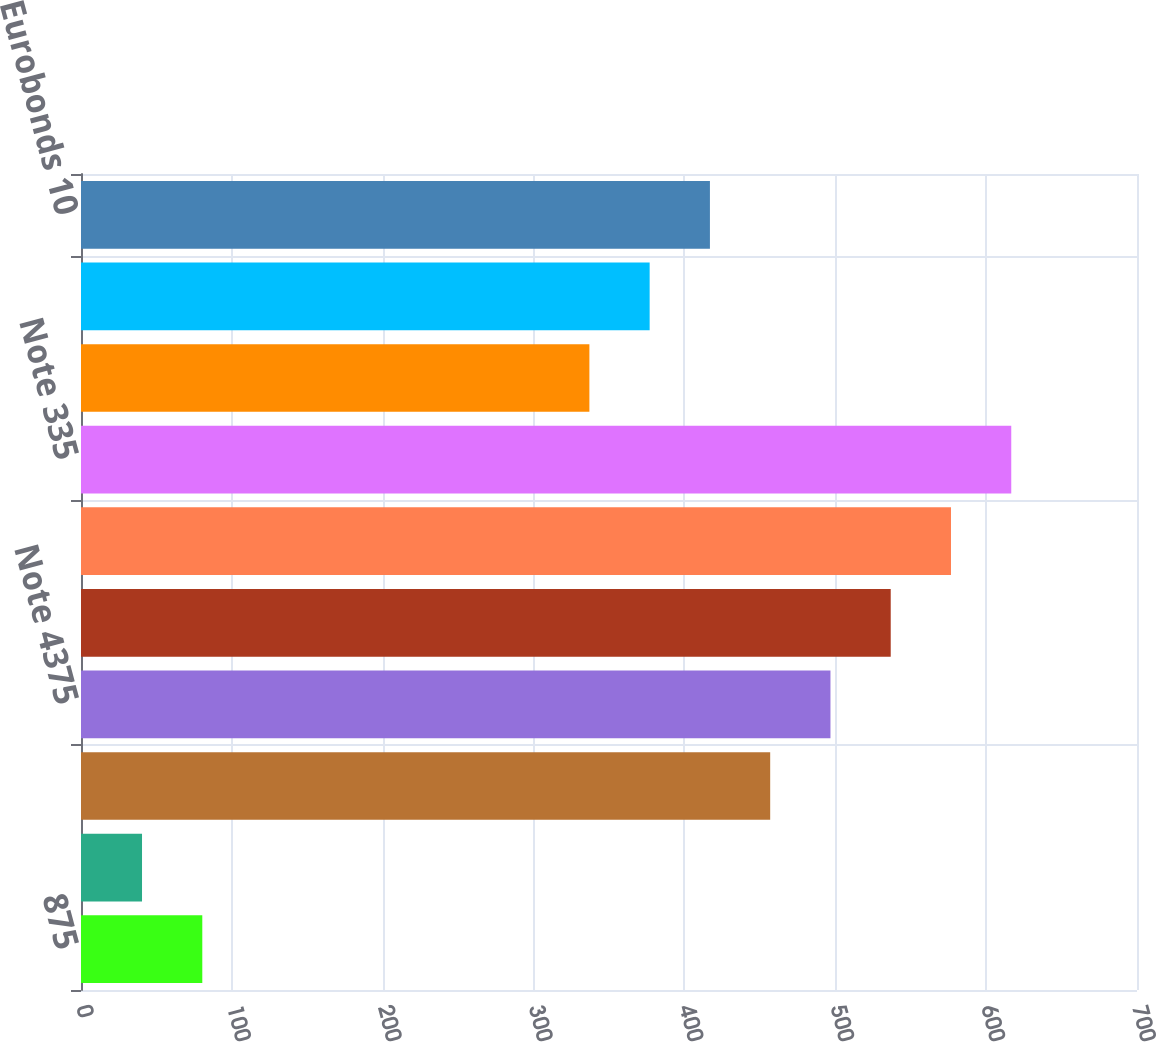Convert chart. <chart><loc_0><loc_0><loc_500><loc_500><bar_chart><fcel>875<fcel>Series E 76<fcel>Note 12<fcel>Note 4375<fcel>Note 30<fcel>Note 275<fcel>Note 335<fcel>Eurobonds 4625<fcel>Eurobonds 20<fcel>Eurobonds 10<nl><fcel>80.4<fcel>40.45<fcel>456.85<fcel>496.8<fcel>536.75<fcel>576.7<fcel>616.65<fcel>337<fcel>376.95<fcel>416.9<nl></chart> 